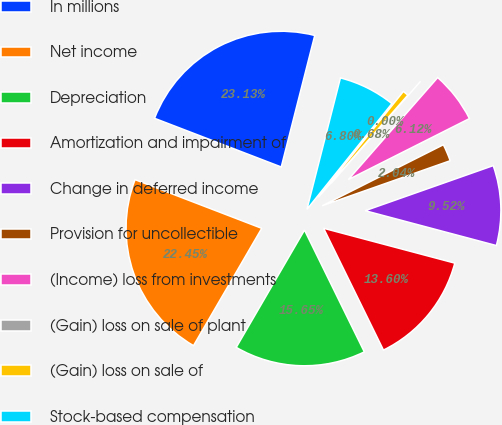Convert chart. <chart><loc_0><loc_0><loc_500><loc_500><pie_chart><fcel>In millions<fcel>Net income<fcel>Depreciation<fcel>Amortization and impairment of<fcel>Change in deferred income<fcel>Provision for uncollectible<fcel>(Income) loss from investments<fcel>(Gain) loss on sale of plant<fcel>(Gain) loss on sale of<fcel>Stock-based compensation<nl><fcel>23.13%<fcel>22.45%<fcel>15.65%<fcel>13.6%<fcel>9.52%<fcel>2.04%<fcel>6.12%<fcel>0.0%<fcel>0.68%<fcel>6.8%<nl></chart> 